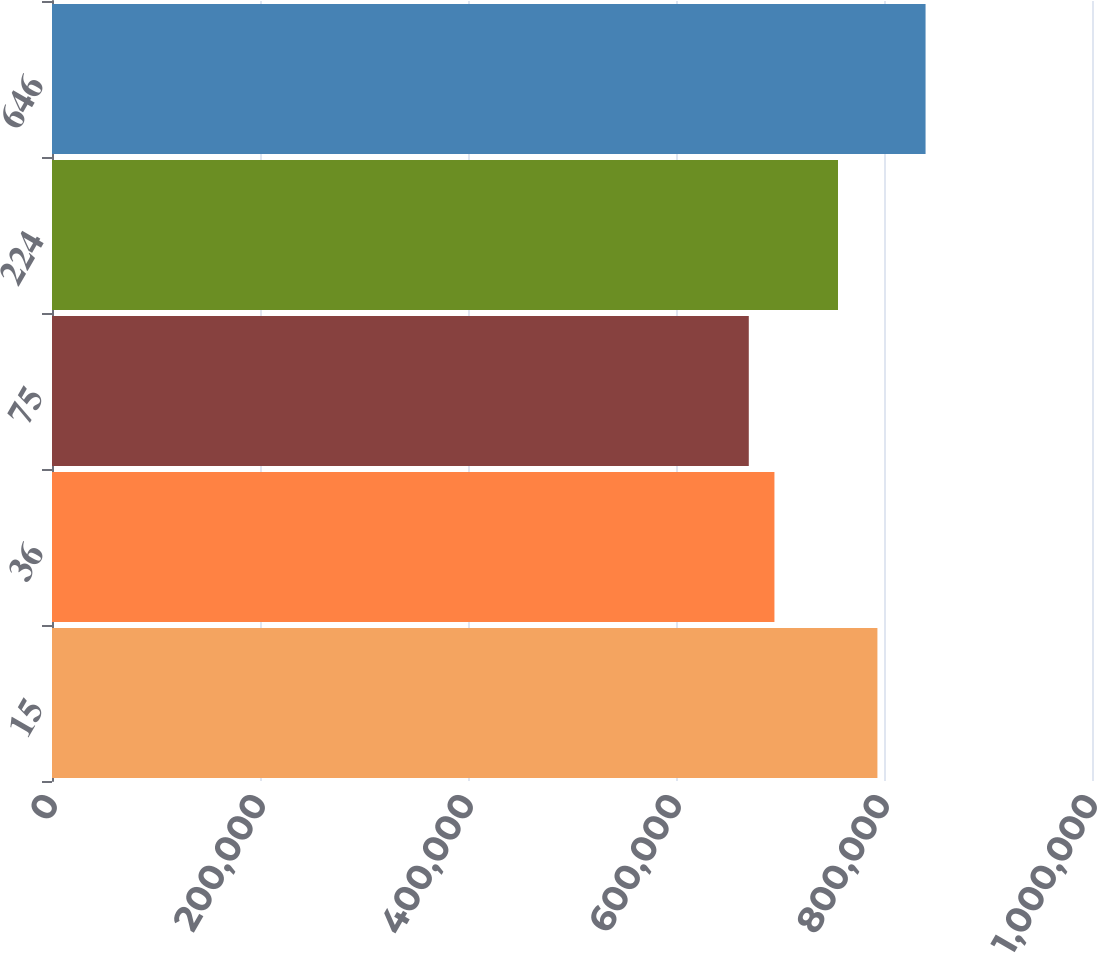Convert chart. <chart><loc_0><loc_0><loc_500><loc_500><bar_chart><fcel>15<fcel>36<fcel>75<fcel>224<fcel>646<nl><fcel>793669<fcel>694650<fcel>669990<fcel>755762<fcel>839962<nl></chart> 